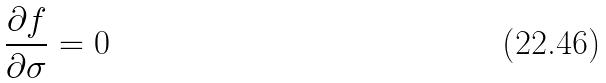<formula> <loc_0><loc_0><loc_500><loc_500>\frac { \partial f } { \partial \sigma } = 0</formula> 